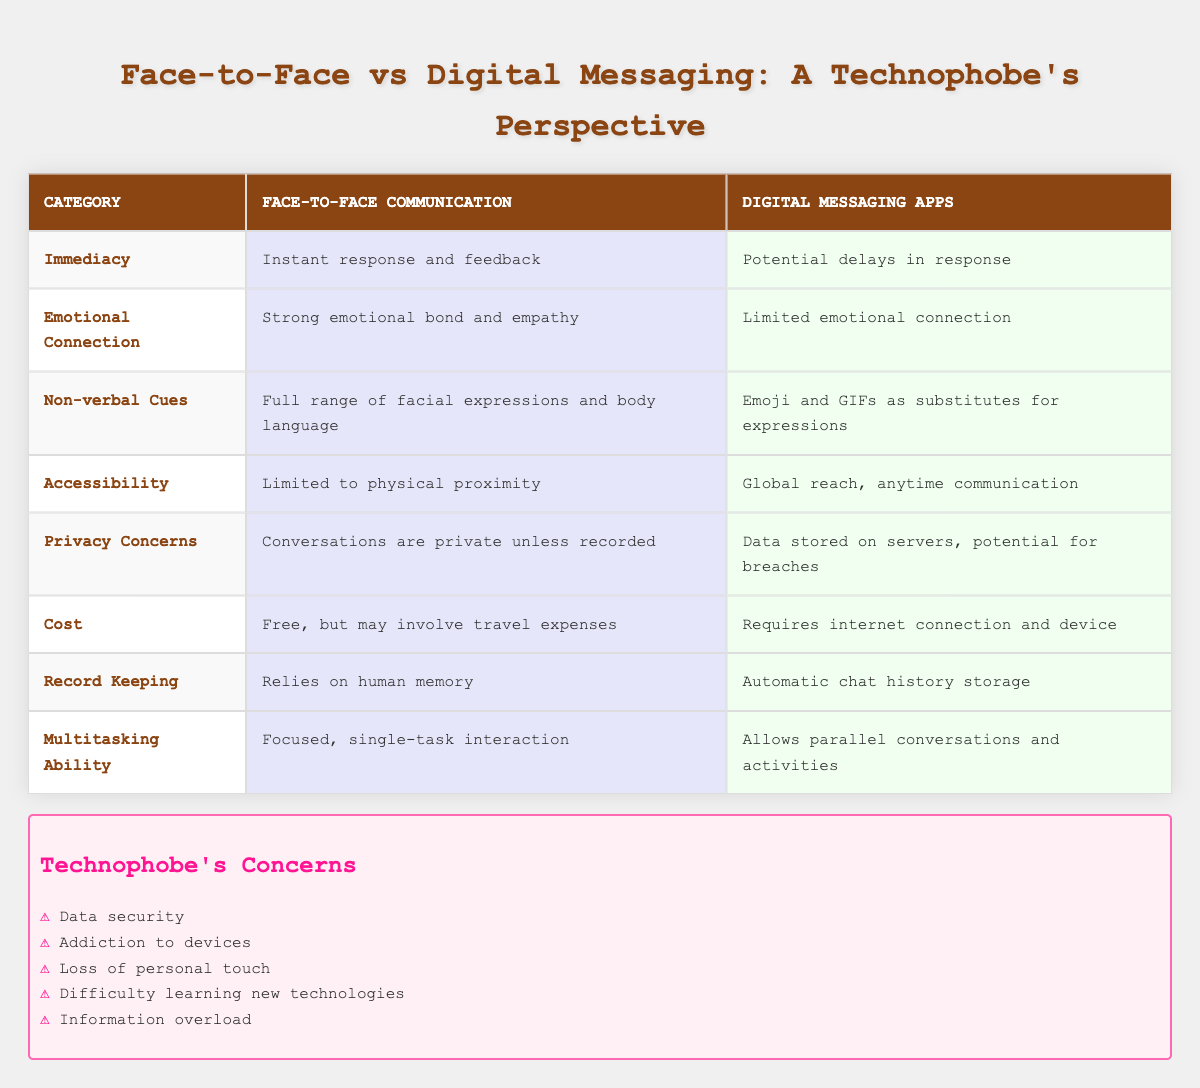What do digital messaging apps allow that face-to-face communication does not? According to the table, digital messaging apps allow for global reach and communication at any time, which is not possible with face-to-face communication that is limited to physical proximity.
Answer: Global reach, anytime communication Which category has the strongest advantage for face-to-face communication? In the "Emotional Connection" category, face-to-face communication demonstrates a strong emotional bond and empathy, which is notably stronger than the limited emotional connection offered by digital messaging apps.
Answer: Emotional Connection Is it true that conversations are private in face-to-face communication? Yes, the table indicates that conversations in face-to-face communication are considered private unless recorded, which affirms the fact about privacy in this method.
Answer: Yes What is the difference in multitasking ability between the two methods? Face-to-face communication is described as a focused, single-task interaction, while digital messaging apps allow for parallel conversations and activities, indicating that digital methods support multitasking.
Answer: Digital messaging supports multitasking How do the privacy concerns of digital messaging apps compare to those of face-to-face communication? Face-to-face communication maintains privacy as conversations are private unless recorded, whereas digital messaging apps have data stored on servers, carrying potential for breaches. This highlights face-to-face communication as more secure in terms of privacy.
Answer: Face-to-face communication is more secure in privacy What could be the potential emotional impact of using digital messaging apps instead of face-to-face communication for important conversations? Since digital messaging apps have a limited emotional connection and rely on emojis and GIFs for expressions, it could negatively impact the emotional depth of important conversations, contrasting the strong emotional bond in face-to-face interactions.
Answer: Reduced emotional depth Which communication method incurs costs related to travel? Face-to-face communication may involve travel expenses, while digital messaging apps only require internet connection and devices, indicating that face-to-face interactions can lead to additional costs unlike digital methods.
Answer: Face-to-face communication incurs travel costs How many advantages does face-to-face communication appear to have over digital messaging apps based on the table? By counting the characteristics listed, face-to-face communication advantages are seen in immediacy, emotional connection, non-verbal cues, and privacy concerns, suggesting four distinct advantages when directly compared.
Answer: Four advantages 